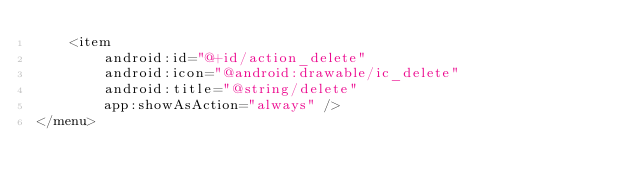<code> <loc_0><loc_0><loc_500><loc_500><_XML_>    <item
        android:id="@+id/action_delete"
        android:icon="@android:drawable/ic_delete"
        android:title="@string/delete"
        app:showAsAction="always" />
</menu></code> 